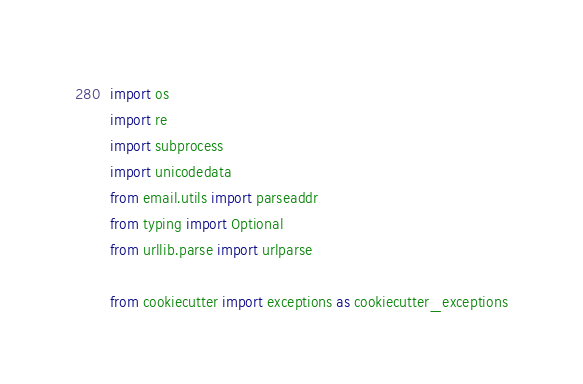<code> <loc_0><loc_0><loc_500><loc_500><_Python_>import os
import re
import subprocess
import unicodedata
from email.utils import parseaddr
from typing import Optional
from urllib.parse import urlparse

from cookiecutter import exceptions as cookiecutter_exceptions
</code> 